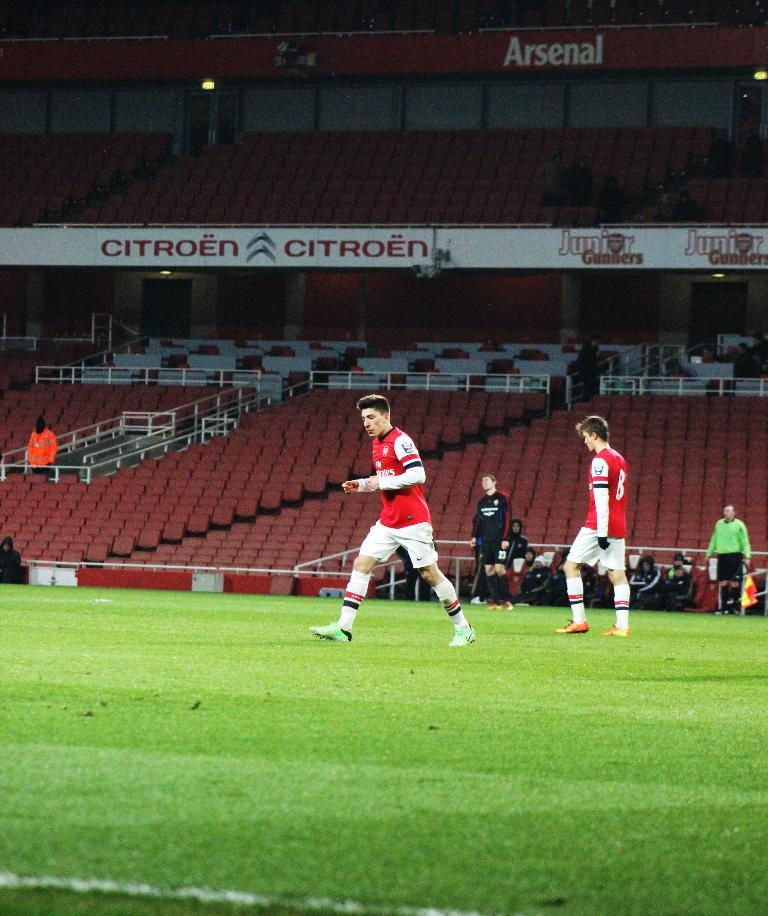<image>
Describe the image concisely. The soccer team in red is sponsored by Emirates airlines. 